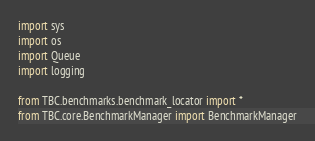Convert code to text. <code><loc_0><loc_0><loc_500><loc_500><_Python_>import sys
import os
import Queue
import logging

from TBC.benchmarks.benchmark_locator import *
from TBC.core.BenchmarkManager import BenchmarkManager</code> 